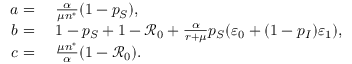<formula> <loc_0><loc_0><loc_500><loc_500>\begin{array} { r l } { a = } & \frac { \alpha } { \mu n ^ { * } } ( 1 - p _ { S } ) , } \\ { b = } & 1 - p _ { S } + 1 - \mathcal { R } _ { 0 } + \frac { \alpha } { r + \mu } p _ { S } ( \varepsilon _ { 0 } + ( 1 - p _ { I } ) \varepsilon _ { 1 } ) , } \\ { c = } & \frac { \mu n ^ { * } } { \alpha } ( 1 - \mathcal { R } _ { 0 } ) . } \end{array}</formula> 